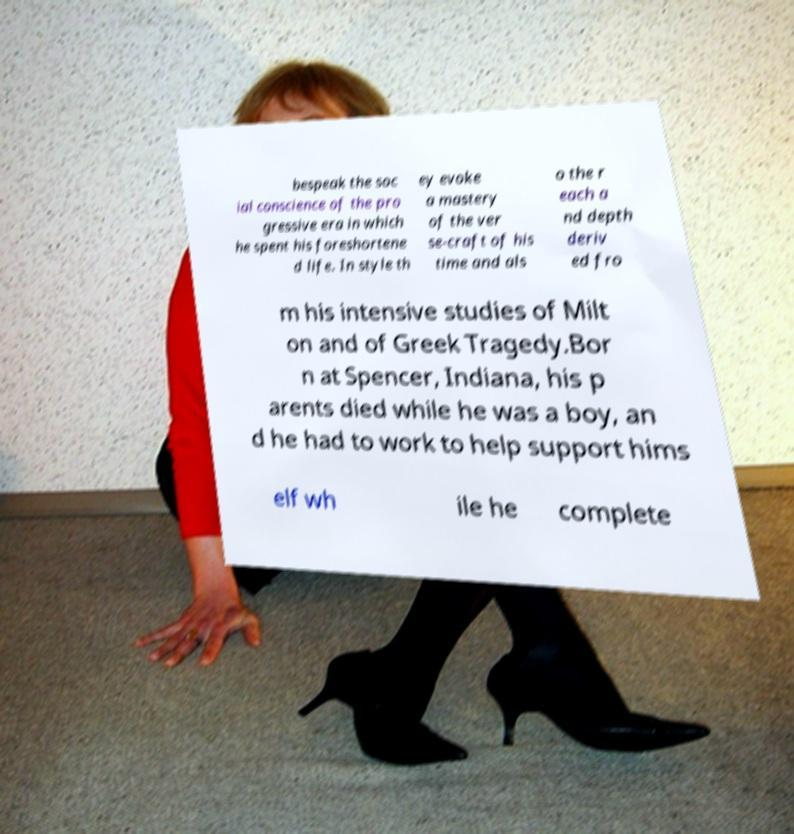Can you read and provide the text displayed in the image?This photo seems to have some interesting text. Can you extract and type it out for me? bespeak the soc ial conscience of the pro gressive era in which he spent his foreshortene d life. In style th ey evoke a mastery of the ver se-craft of his time and als o the r each a nd depth deriv ed fro m his intensive studies of Milt on and of Greek Tragedy.Bor n at Spencer, Indiana, his p arents died while he was a boy, an d he had to work to help support hims elf wh ile he complete 